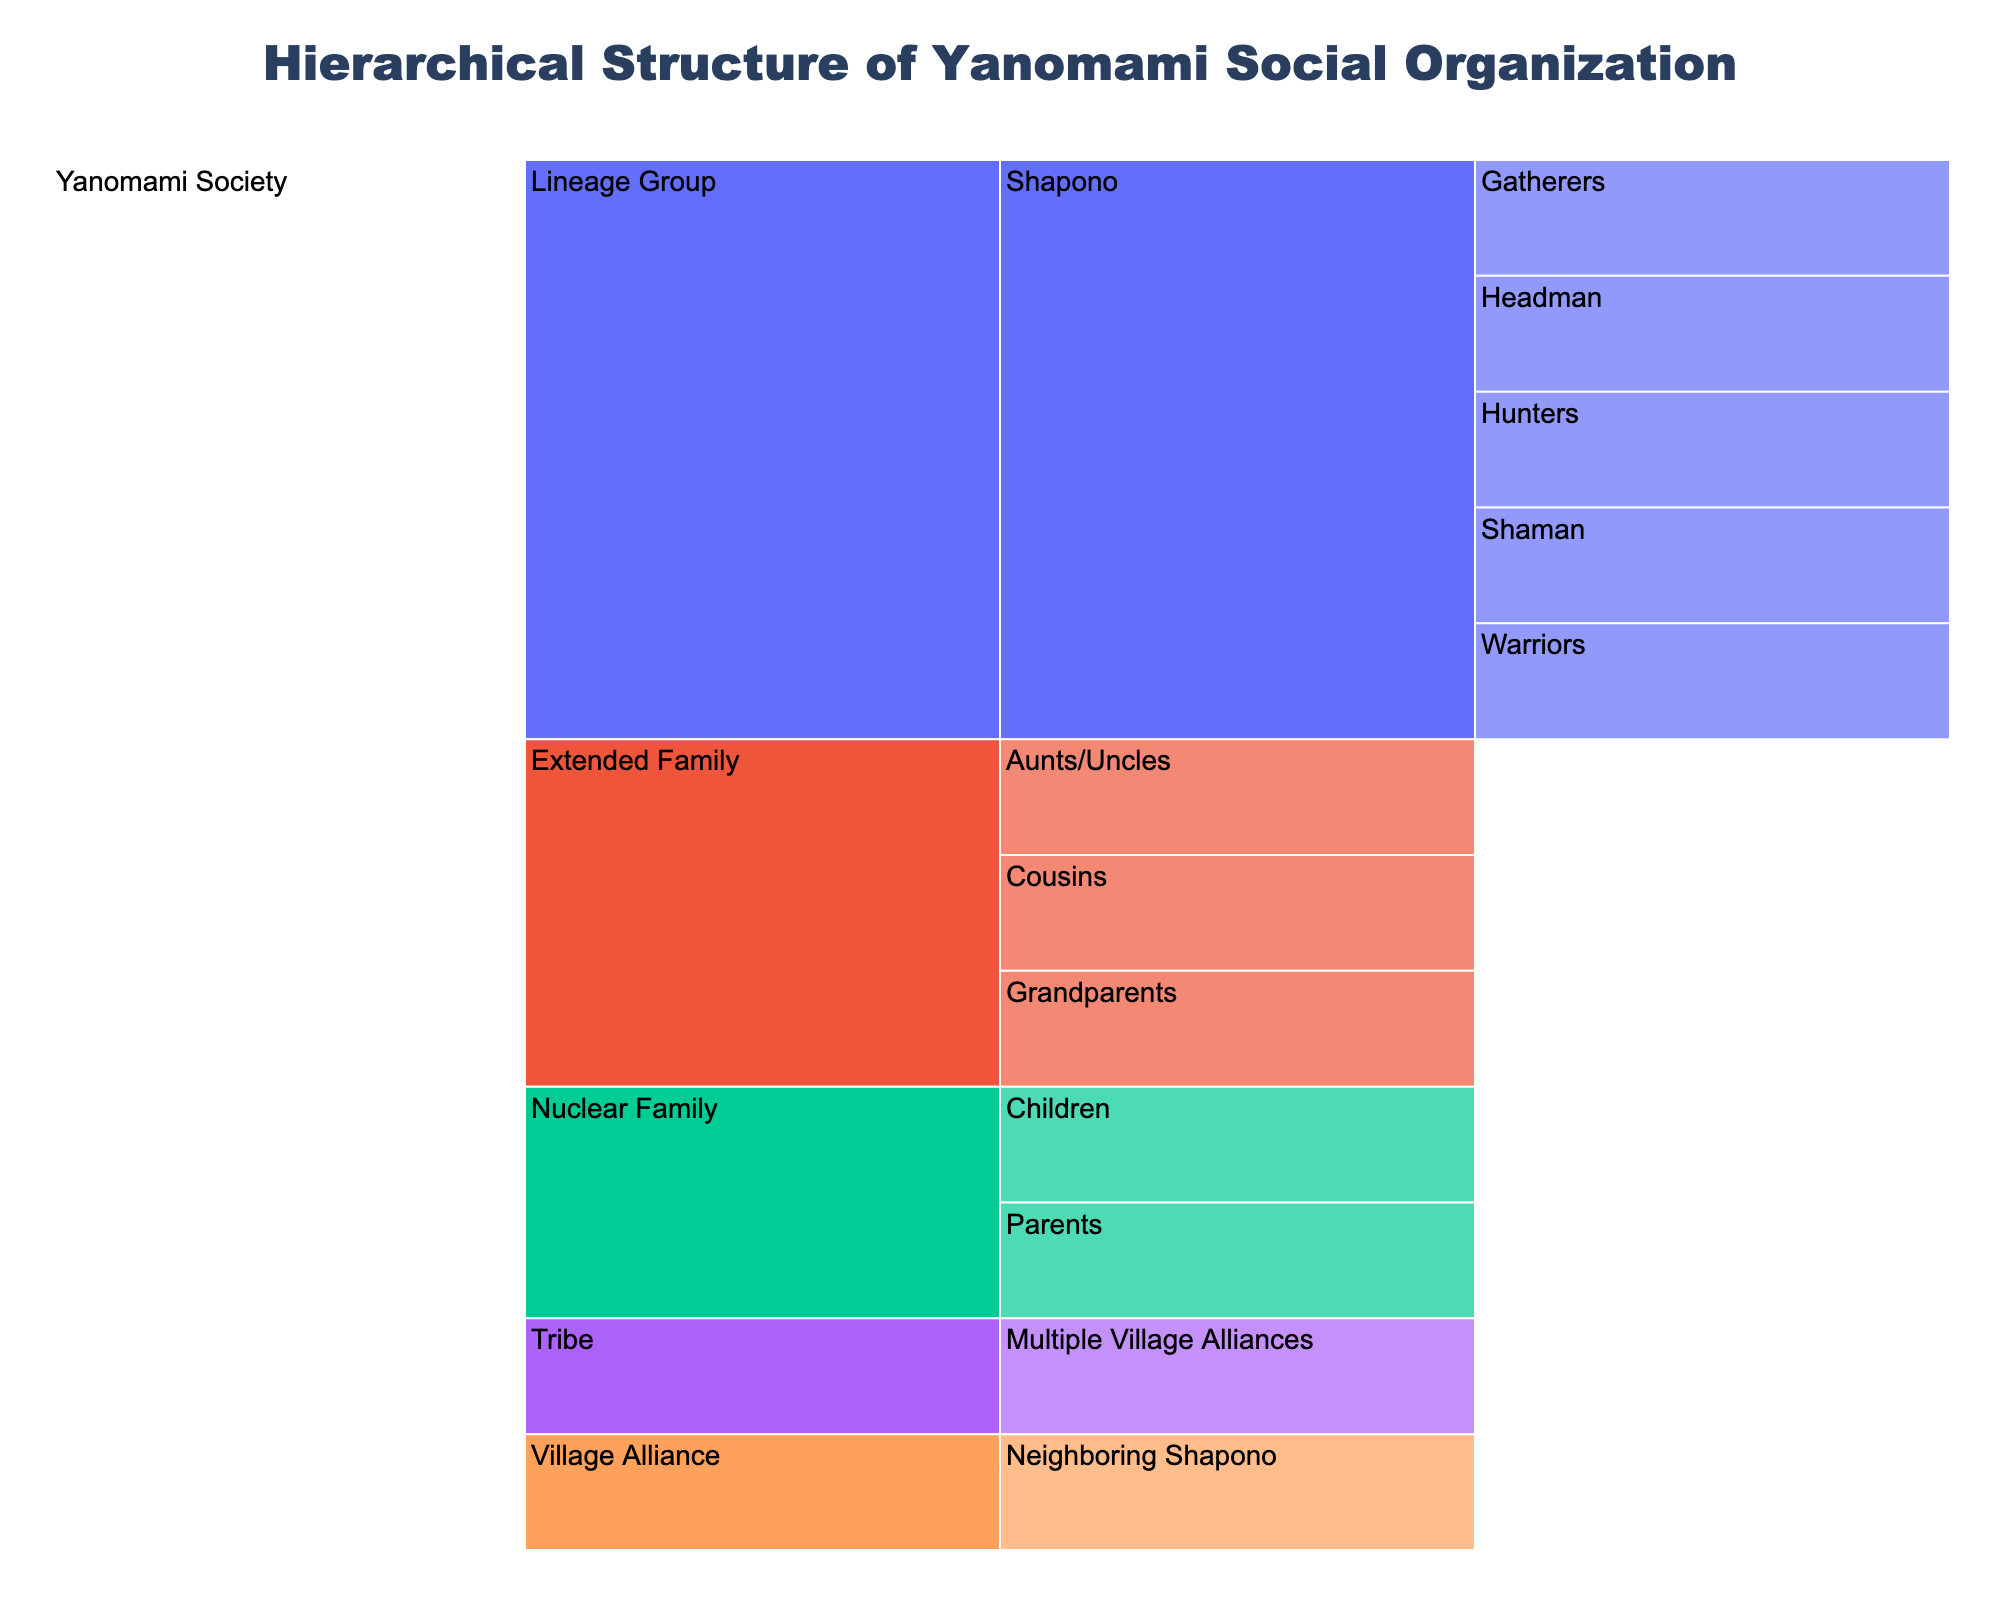What's the title of the figure? The title of the figure can be found at the top of the chart. It describes what the chart is about.
Answer: Hierarchical Structure of Yanomami Social Organization What color scheme is used in the chart? The color scheme refers to the range of colors applied to different sections of the icicle chart. Typically, this can be identified by observing the gradient or palette used.
Answer: YlOrRd How many categories fall under the Nuclear Family level? The Nuclear Family level is a sub-category under Yanomami Society. By counting the immediate segments below Nuclear Family, we can determine the number of categories.
Answer: 2 What is the relationship between Shapono and the headman? To determine the relationship, we trace the hierarchical structure; Shapono is a subgroup under Lineage Group, and under Shapono, the Headman is listed as one component.
Answer: Headman is a subgroup under Shapono How many categories are there in total under the Lineage Group level? We need to count all the subcategories directly under Lineage Group and its sub level. Each direct subgroup — Shapono — contains several subcategories: Headman, Shaman, Warriors, Hunters, and Gatherers.
Answer: 5 Which level contains the Grandparents category? By tracing the hierarchy, we observe that Grandparents are part of the Extended Family level.
Answer: Extended Family level Are there more categories under the Village Alliance or Tribe levels? By counting the subcategories under each level, we determine which contains more. Village Alliance includes Neighboring Shapono, and Tribe encompasses Multiple Village Alliances.
Answer: Village Alliance has more categories What is the broadest category within Yanomami Society? The broadest category is at the top level, encapsulating all other levels within the hierarchy.
Answer: Yanomami Society Which category is directly related to the Shaman? By examining the structure, see where Shaman is positioned within the hierarchy; it falls under Shapono within Lineage Group.
Answer: Shapono What groups fall under the Extended Family? We can identify these by listing all the subcategories under the Extended Family level.
Answer: Grandparents, Aunts/Uncles, Cousins 